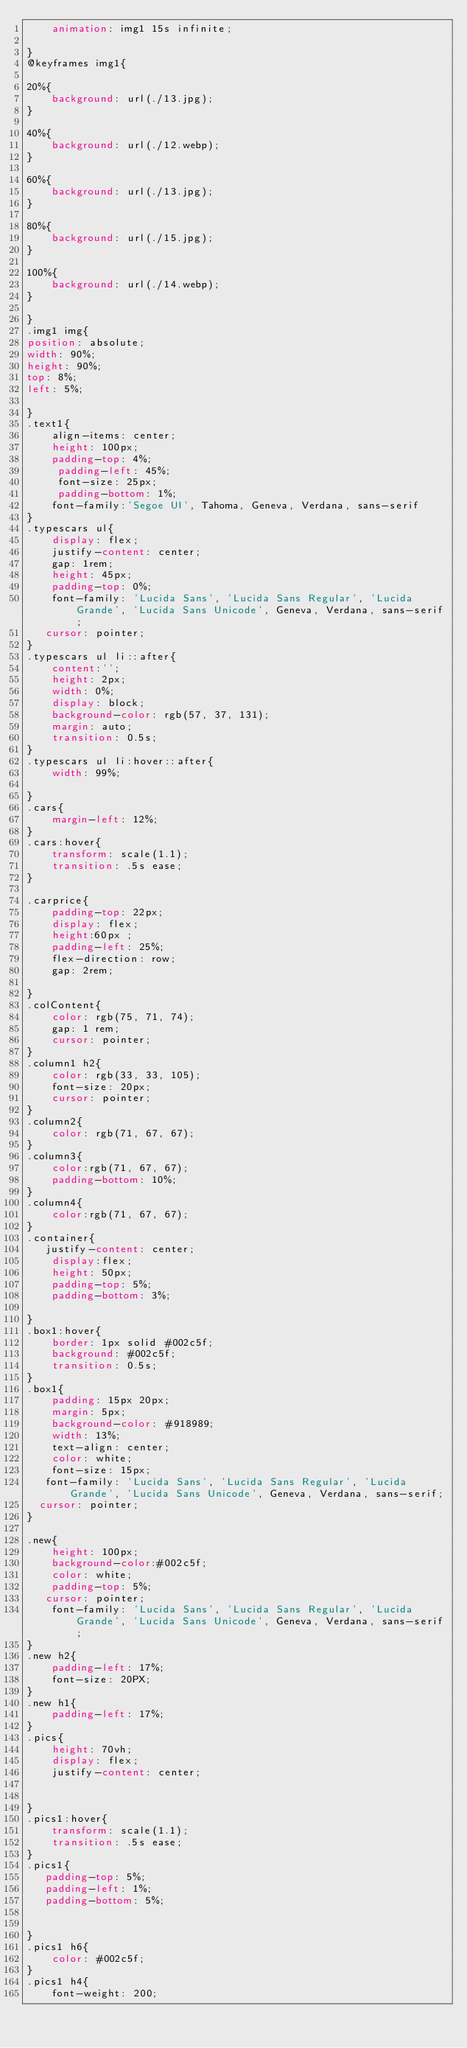Convert code to text. <code><loc_0><loc_0><loc_500><loc_500><_CSS_>    animation: img1 15s infinite;

}
@keyframes img1{

20%{
    background: url(./13.jpg);
}

40%{
    background: url(./12.webp);
}

60%{
    background: url(./13.jpg);
}

80%{
    background: url(./15.jpg);
}

100%{
    background: url(./14.webp);
}

}
.img1 img{
position: absolute;
width: 90%;
height: 90%;
top: 8%;
left: 5%;

}
.text1{
    align-items: center;
    height: 100px;
    padding-top: 4%;
     padding-left: 45%;
     font-size: 25px;
     padding-bottom: 1%;
    font-family:'Segoe UI', Tahoma, Geneva, Verdana, sans-serif
}
.typescars ul{
    display: flex;
    justify-content: center;
    gap: 1rem;
    height: 45px;
    padding-top: 0%;
    font-family: 'Lucida Sans', 'Lucida Sans Regular', 'Lucida Grande', 'Lucida Sans Unicode', Geneva, Verdana, sans-serif;
   cursor: pointer;
}
.typescars ul li::after{
    content:'';
    height: 2px;
    width: 0%;
    display: block;
    background-color: rgb(57, 37, 131);
    margin: auto;
    transition: 0.5s;
}
.typescars ul li:hover::after{
    width: 99%;

}
.cars{
    margin-left: 12%;
}
.cars:hover{
    transform: scale(1.1);
    transition: .5s ease;
}

.carprice{
    padding-top: 22px;
    display: flex;
    height:60px ;
    padding-left: 25%;
    flex-direction: row;
    gap: 2rem;

}
.colContent{
    color: rgb(75, 71, 74);
    gap: 1 rem;
    cursor: pointer;
}
.column1 h2{
    color: rgb(33, 33, 105);
    font-size: 20px;
    cursor: pointer;
}
.column2{
    color: rgb(71, 67, 67);
}
.column3{
    color:rgb(71, 67, 67);
    padding-bottom: 10%;
}
.column4{
    color:rgb(71, 67, 67);
}
.container{
   justify-content: center;
    display:flex;
    height: 50px;
    padding-top: 5%;
    padding-bottom: 3%;

}
.box1:hover{
    border: 1px solid #002c5f;
    background: #002c5f;
    transition: 0.5s;
}
.box1{
    padding: 15px 20px;
    margin: 5px;
    background-color: #918989;
    width: 13%;
    text-align: center;
    color: white;
    font-size: 15px;
   font-family: 'Lucida Sans', 'Lucida Sans Regular', 'Lucida Grande', 'Lucida Sans Unicode', Geneva, Verdana, sans-serif;
  cursor: pointer;
}

.new{
    height: 100px;
    background-color:#002c5f;
    color: white;
    padding-top: 5%;
   cursor: pointer;
    font-family: 'Lucida Sans', 'Lucida Sans Regular', 'Lucida Grande', 'Lucida Sans Unicode', Geneva, Verdana, sans-serif;
}
.new h2{
    padding-left: 17%;
    font-size: 20PX;
}
.new h1{
    padding-left: 17%;
}
.pics{
    height: 70vh;
    display: flex;
    justify-content: center;

    
}
.pics1:hover{
    transform: scale(1.1);
    transition: .5s ease;
}
.pics1{
   padding-top: 5%;
   padding-left: 1%;
   padding-bottom: 5%;
   
   
}
.pics1 h6{
    color: #002c5f;
}
.pics1 h4{
    font-weight: 200;</code> 